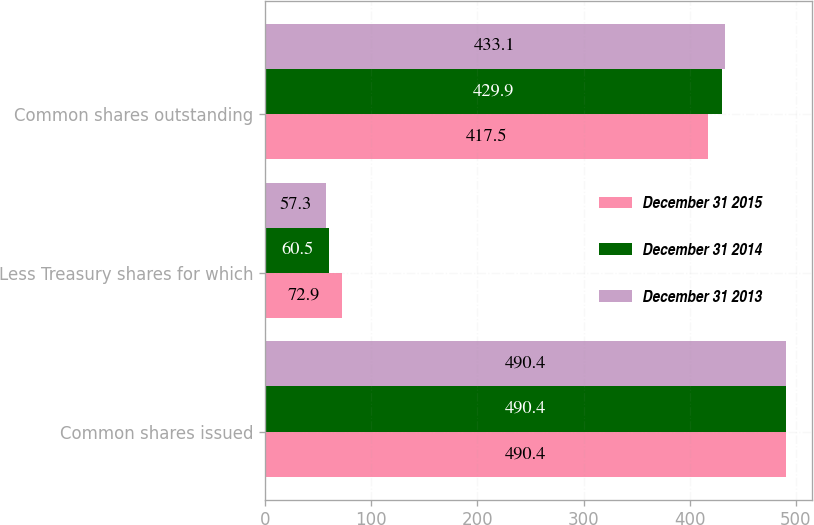Convert chart to OTSL. <chart><loc_0><loc_0><loc_500><loc_500><stacked_bar_chart><ecel><fcel>Common shares issued<fcel>Less Treasury shares for which<fcel>Common shares outstanding<nl><fcel>December 31 2015<fcel>490.4<fcel>72.9<fcel>417.5<nl><fcel>December 31 2014<fcel>490.4<fcel>60.5<fcel>429.9<nl><fcel>December 31 2013<fcel>490.4<fcel>57.3<fcel>433.1<nl></chart> 